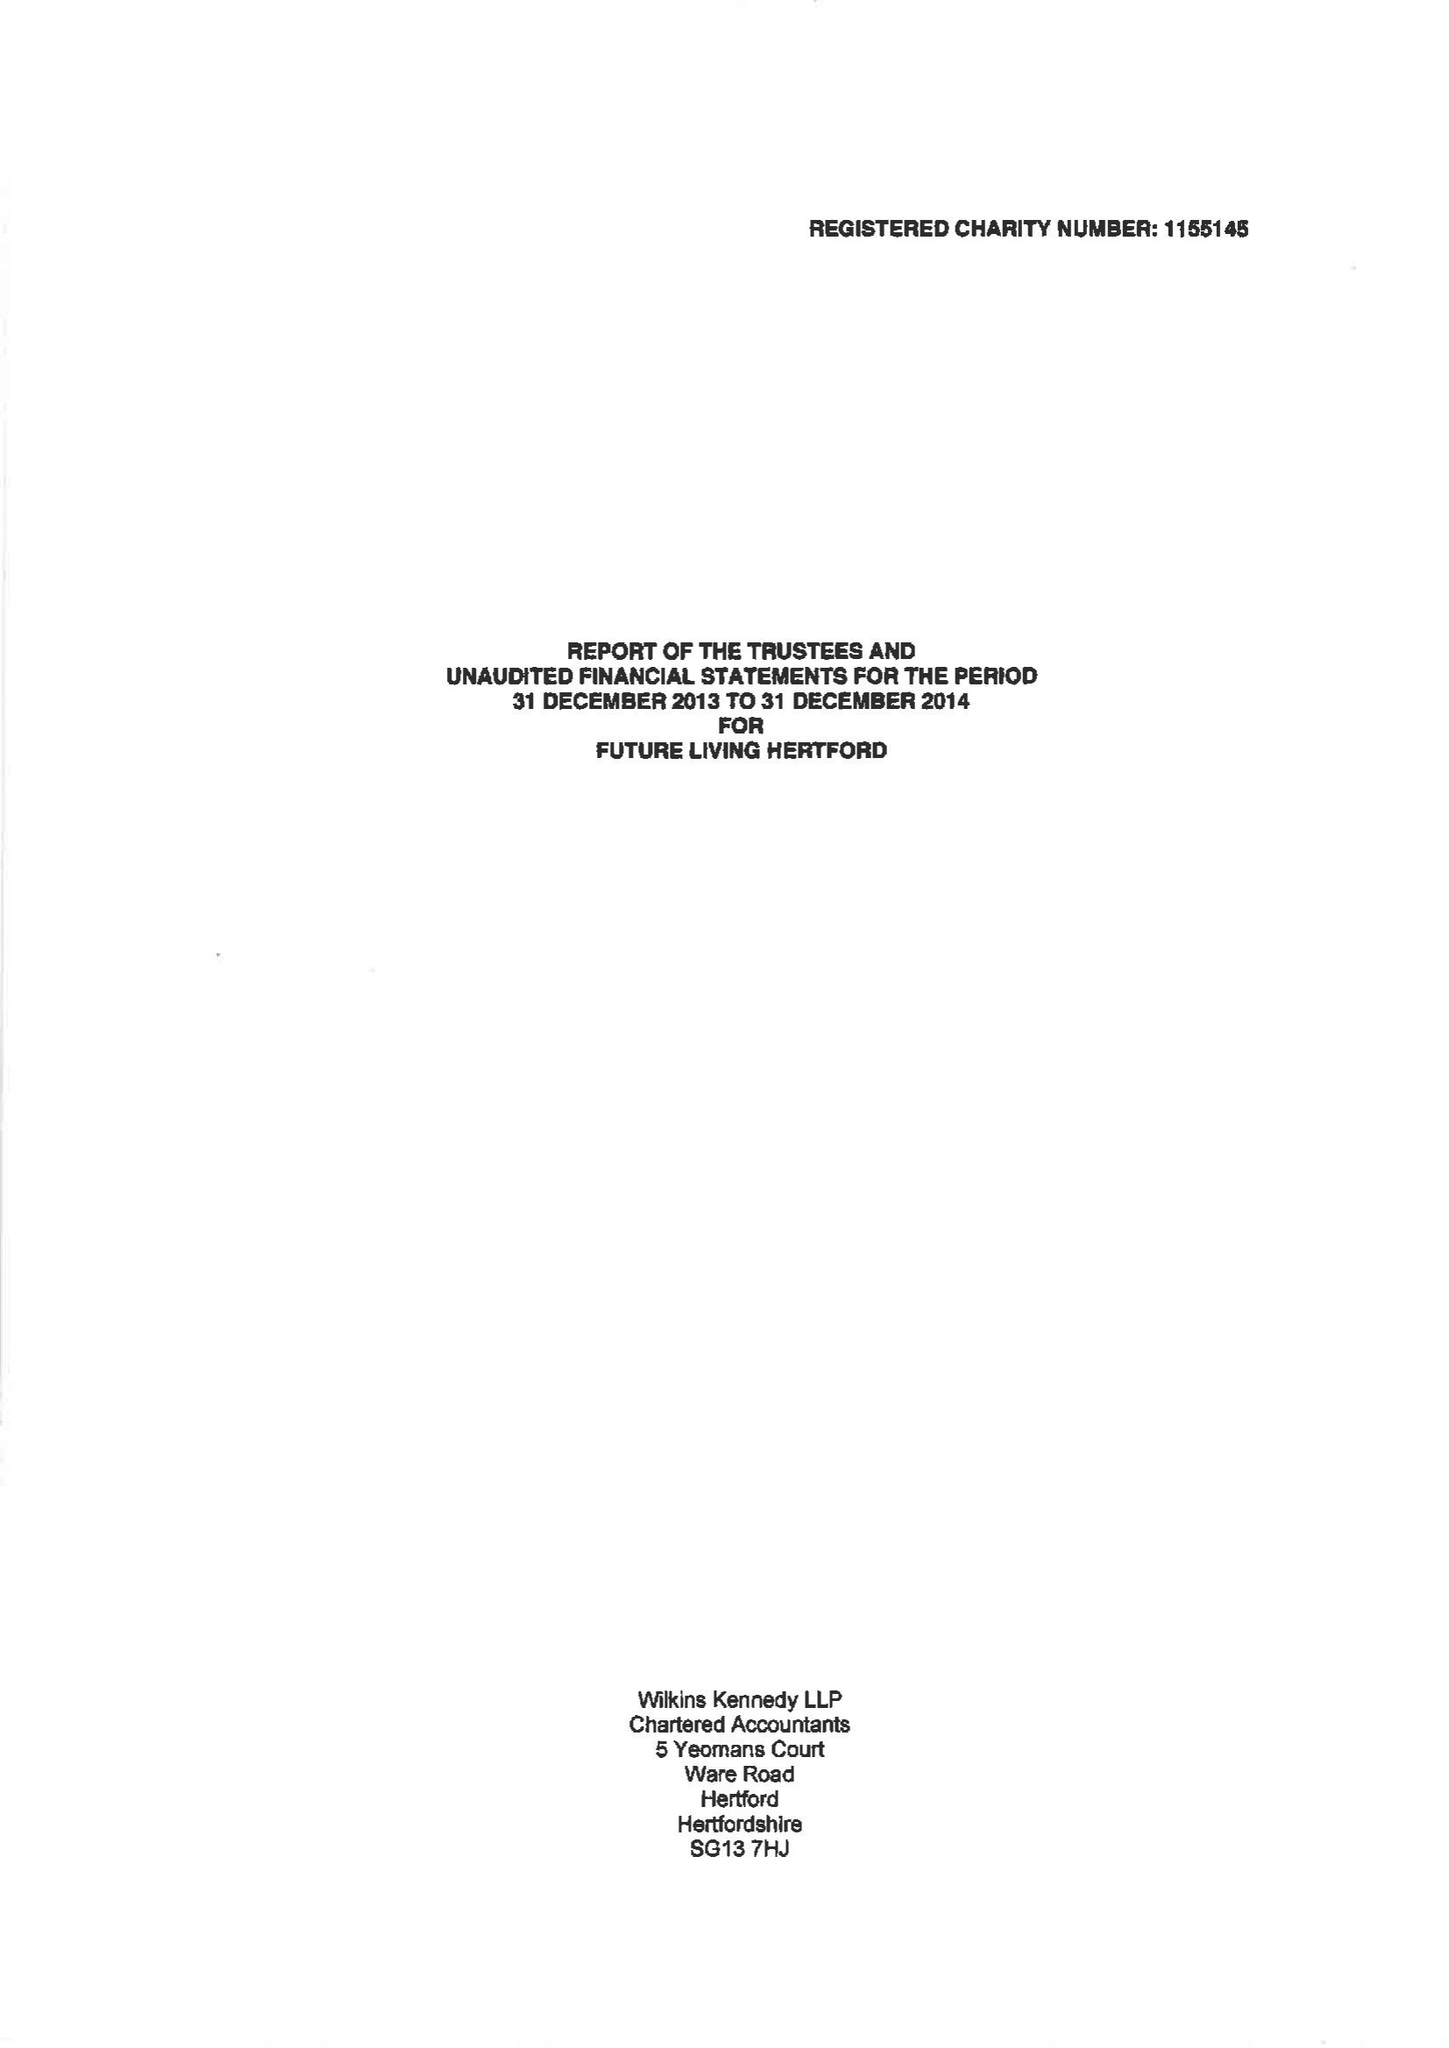What is the value for the address__postcode?
Answer the question using a single word or phrase. SG14 1PN 